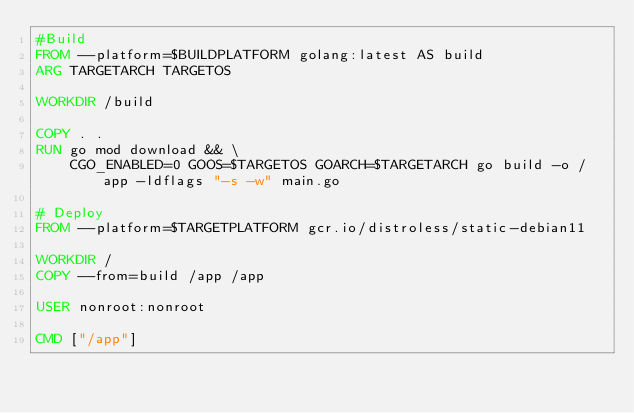<code> <loc_0><loc_0><loc_500><loc_500><_Dockerfile_>#Build
FROM --platform=$BUILDPLATFORM golang:latest AS build
ARG TARGETARCH TARGETOS

WORKDIR /build

COPY . .
RUN go mod download && \
    CGO_ENABLED=0 GOOS=$TARGETOS GOARCH=$TARGETARCH go build -o /app -ldflags "-s -w" main.go

# Deploy
FROM --platform=$TARGETPLATFORM gcr.io/distroless/static-debian11

WORKDIR /
COPY --from=build /app /app

USER nonroot:nonroot

CMD ["/app"]
</code> 